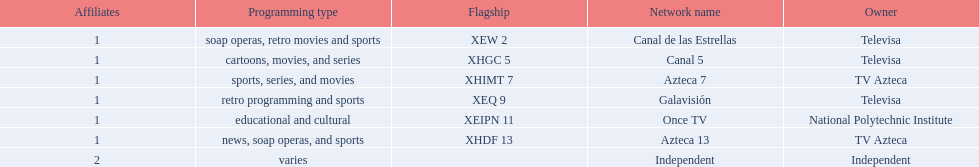What stations show sports? Soap operas, retro movies and sports, retro programming and sports, news, soap operas, and sports. What of these is not affiliated with televisa? Azteca 7. 